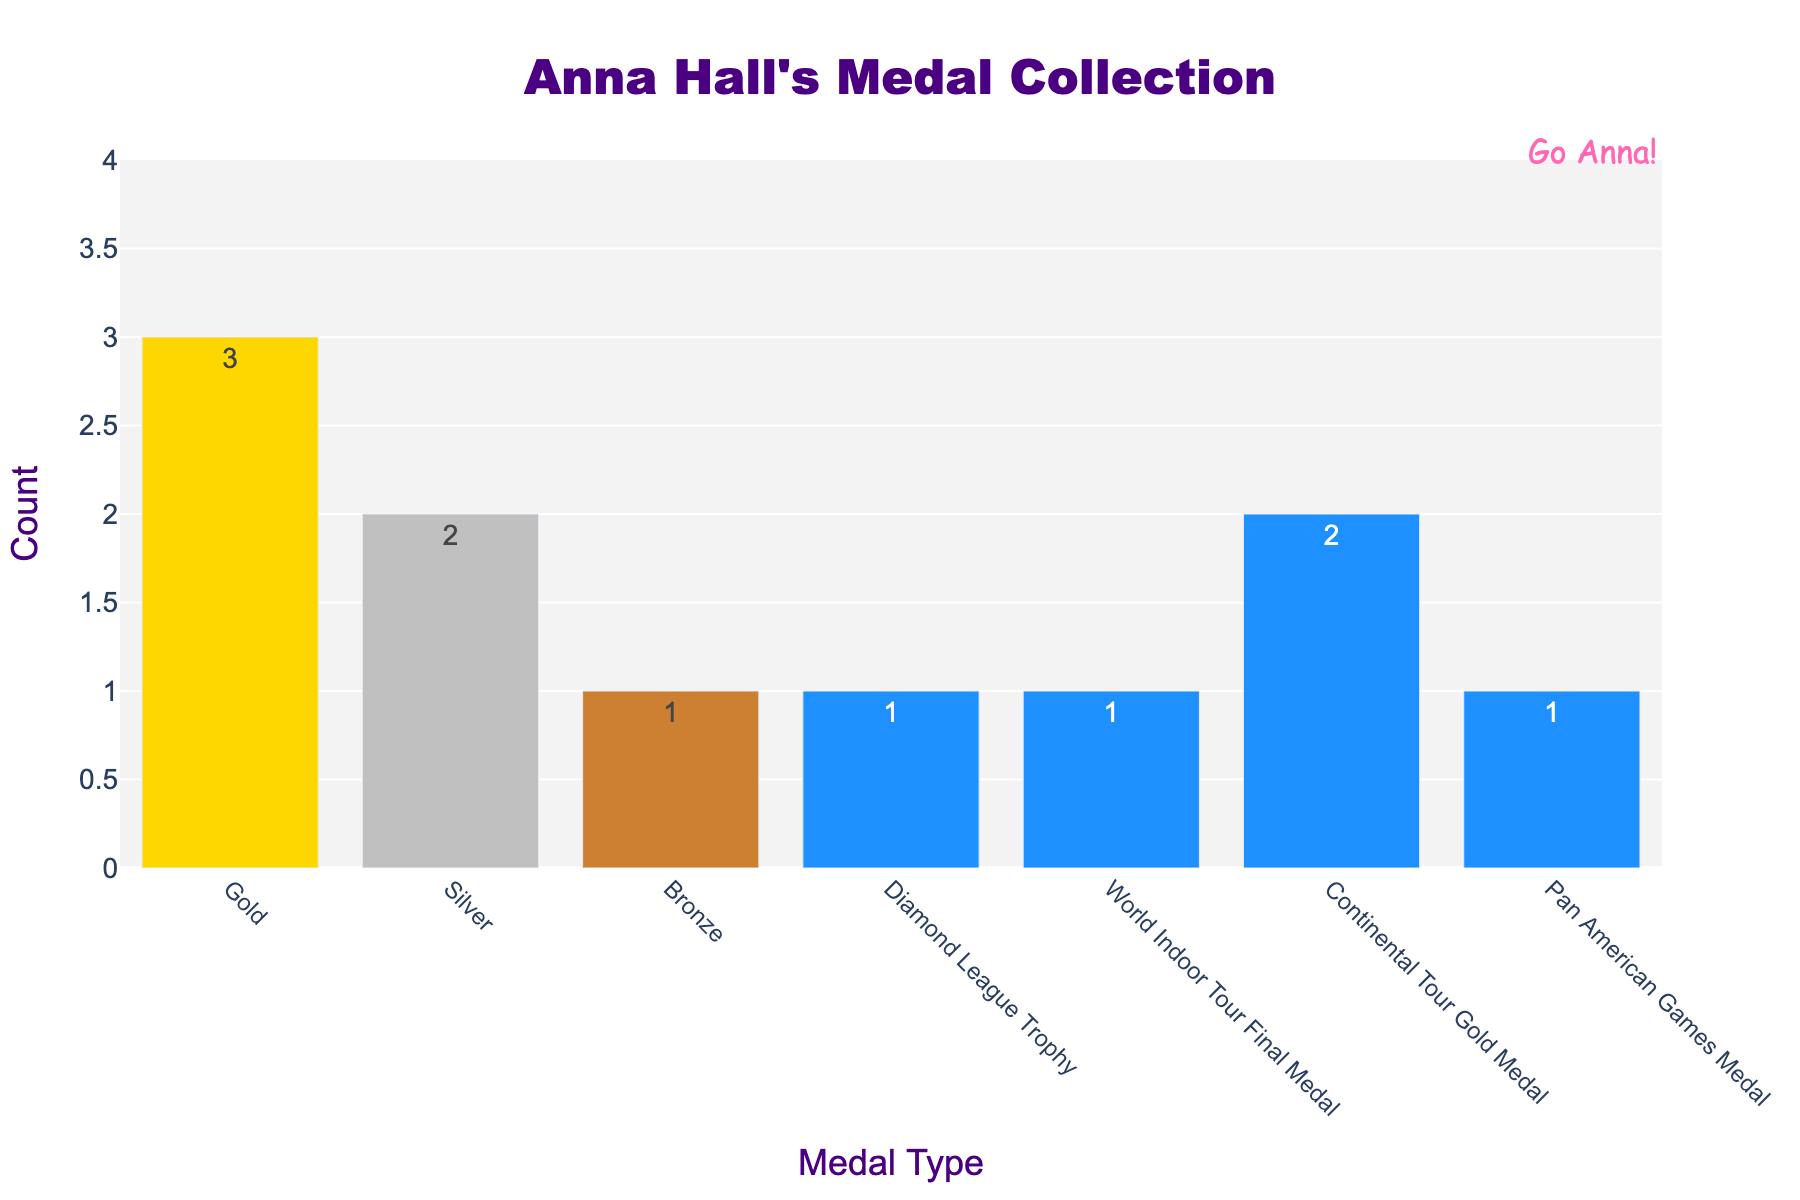Which medal type did Anna win the most? The bar for "Gold" is the tallest, indicating that Anna won the most Gold medals.
Answer: Gold How many total medals has Anna Hall won? By summing the counts for each medal type: 3 (Gold) + 2 (Silver) + 1 (Bronze) + 1 (Diamond League Trophy) + 1 (World Indoor Tour Final Medal) + 2 (Continental Tour Gold Medal) + 1 (Pan American Games Medal) = 11.
Answer: 11 How does the number of Silver medals compare to the number of Bronze medals? The bar representing Silver medals has a value of 2, while the bar representing Bronze medals has a value of 1. Therefore, Anna won more Silver medals than Bronze medals.
Answer: Silver medals are greater than Bronze medals What's the difference between the number of Gold medals and Continental Tour Gold Medals won by Anna? The difference is found by subtracting the Continental Tour Gold Medal count from the Gold medal count: 3 (Gold) - 2 (Continental Tour Gold Medal) = 1.
Answer: 1 What is the combined total of Gold, Silver, and Bronze medals won by Anna? Adding the counts for Gold, Silver, and Bronze medals: 3 (Gold) + 2 (Silver) + 1 (Bronze) = 6.
Answer: 6 Which medal types has Anna won exactly twice? The bars representing "Silver" and "Continental Tour Gold Medal" both show a count of 2.
Answer: Silver and Continental Tour Gold Medal Are there any medal types that Anna has won more than once but fewer than three times? By examining the bars, the medal types with counts between 1 and 2 are "Silver" and "Continental Tour Gold Medal", both with a count of 2.
Answer: Silver and Continental Tour Gold Medal What is the tallest bar's color on the graph? The color of the tallest bar, which represents Gold medals, is yellow.
Answer: Yellow How does the count of Diamond League Trophies compare to the count of Pan American Games Medals? Both bars show a count of 1, indicating Anna has won the same number of Diamond League Trophies and Pan American Games Medals.
Answer: Equal Which medal types has Anna won only once? The bars with a count of 1 are "Bronze," "Diamond League Trophy," "World Indoor Tour Final Medal," and "Pan American Games Medal."
Answer: Bronze, Diamond League Trophy, World Indoor Tour Final Medal, Pan American Games Medal 